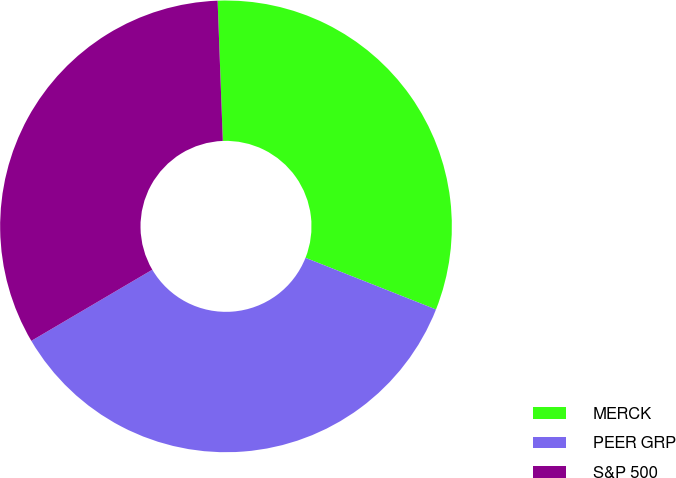Convert chart to OTSL. <chart><loc_0><loc_0><loc_500><loc_500><pie_chart><fcel>MERCK<fcel>PEER GRP<fcel>S&P 500<nl><fcel>31.59%<fcel>35.54%<fcel>32.87%<nl></chart> 